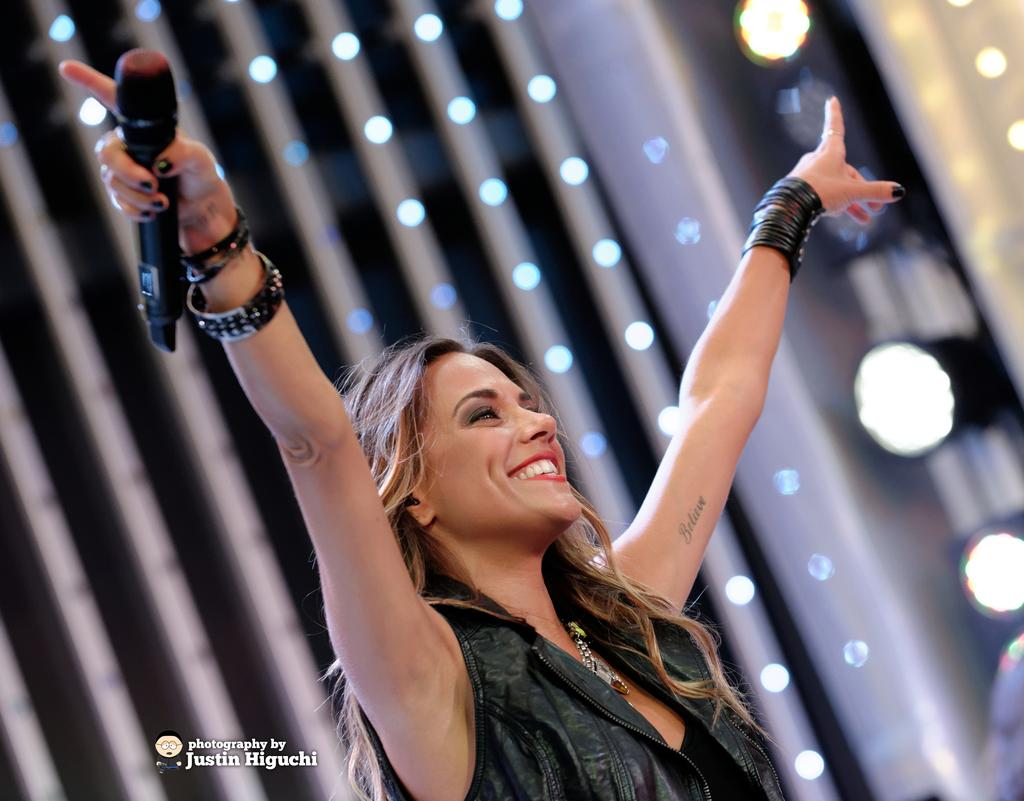Who is present in the image? There is a woman in the picture. What is the woman doing in the image? The woman is smiling in the image. What object is the woman holding in her hand? The woman is holding a microphone in her hand. What type of sack can be seen in the image? There is no sack present in the image. How is the woman using the screw in the image? There is no screw present in the image. 